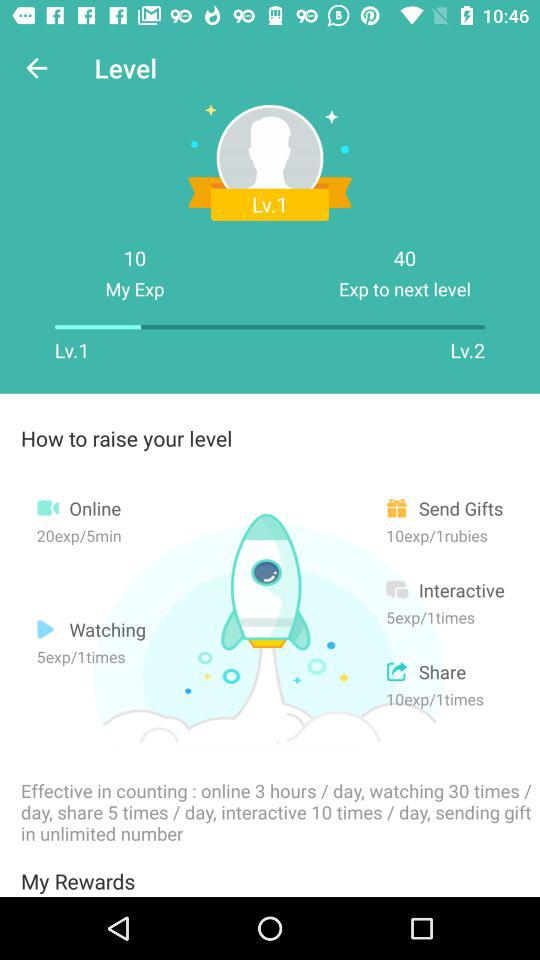What is the value of "My Exp" at level 1? The value is 10. 